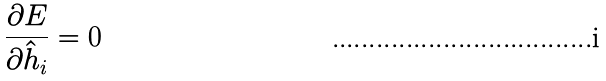<formula> <loc_0><loc_0><loc_500><loc_500>\frac { \partial E } { \partial \hat { h } _ { i } } = 0</formula> 